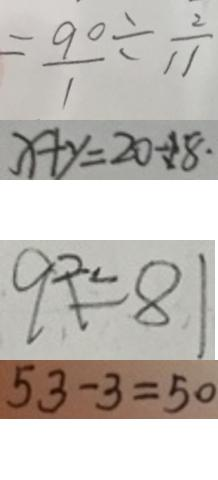<formula> <loc_0><loc_0><loc_500><loc_500>= \frac { 9 0 } { 1 } \div \frac { 2 } { 1 1 } 
 x + y = 2 0 \div 1 8 \cdot 
 9 ^ { 2 . } = 8 1 
 5 3 - 3 = 5 0</formula> 